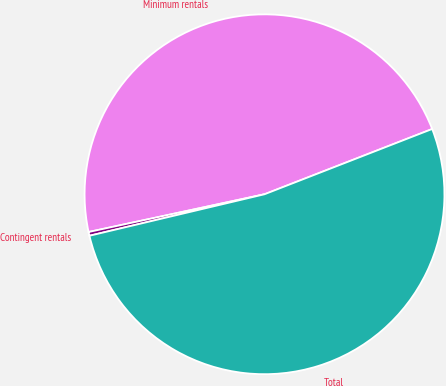<chart> <loc_0><loc_0><loc_500><loc_500><pie_chart><fcel>Minimum rentals<fcel>Contingent rentals<fcel>Total<nl><fcel>47.46%<fcel>0.34%<fcel>52.21%<nl></chart> 